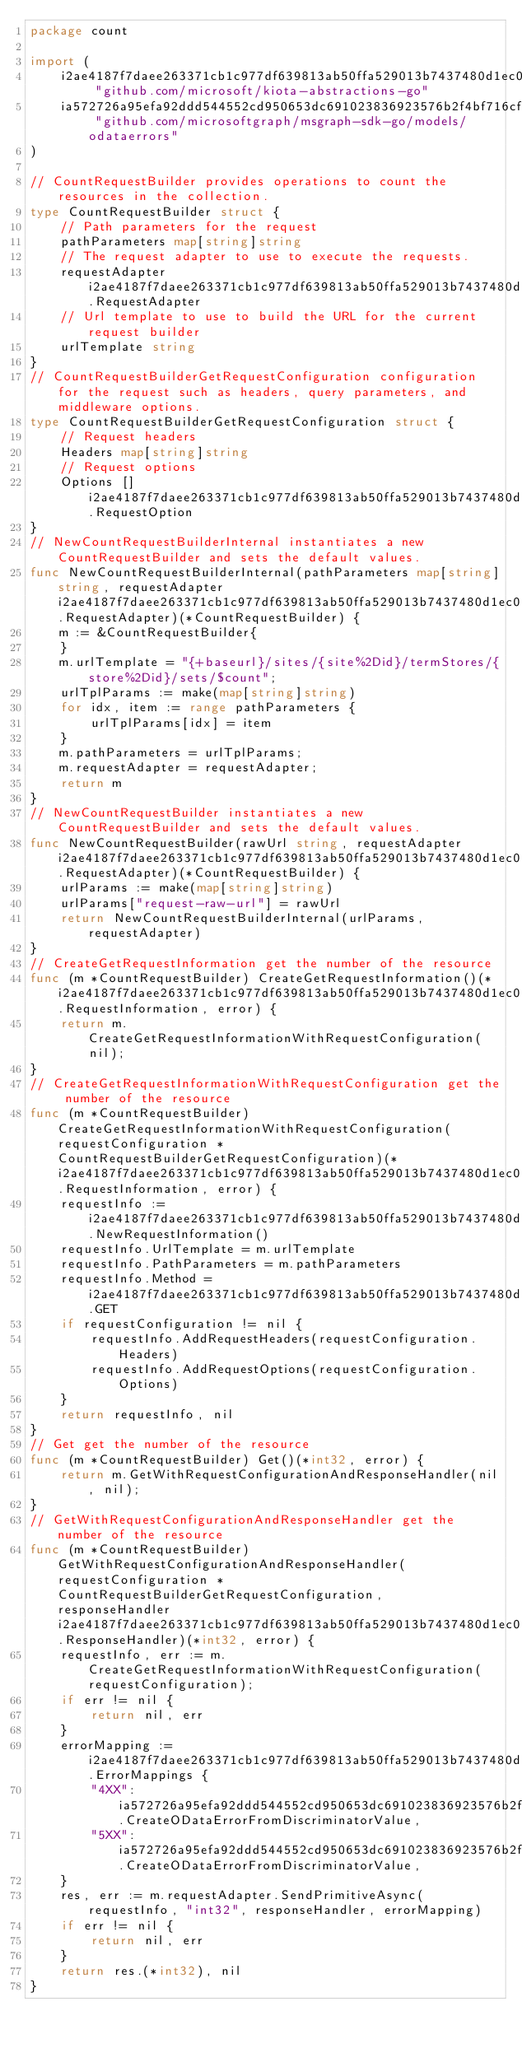Convert code to text. <code><loc_0><loc_0><loc_500><loc_500><_Go_>package count

import (
    i2ae4187f7daee263371cb1c977df639813ab50ffa529013b7437480d1ec0158f "github.com/microsoft/kiota-abstractions-go"
    ia572726a95efa92ddd544552cd950653dc691023836923576b2f4bf716cf204a "github.com/microsoftgraph/msgraph-sdk-go/models/odataerrors"
)

// CountRequestBuilder provides operations to count the resources in the collection.
type CountRequestBuilder struct {
    // Path parameters for the request
    pathParameters map[string]string
    // The request adapter to use to execute the requests.
    requestAdapter i2ae4187f7daee263371cb1c977df639813ab50ffa529013b7437480d1ec0158f.RequestAdapter
    // Url template to use to build the URL for the current request builder
    urlTemplate string
}
// CountRequestBuilderGetRequestConfiguration configuration for the request such as headers, query parameters, and middleware options.
type CountRequestBuilderGetRequestConfiguration struct {
    // Request headers
    Headers map[string]string
    // Request options
    Options []i2ae4187f7daee263371cb1c977df639813ab50ffa529013b7437480d1ec0158f.RequestOption
}
// NewCountRequestBuilderInternal instantiates a new CountRequestBuilder and sets the default values.
func NewCountRequestBuilderInternal(pathParameters map[string]string, requestAdapter i2ae4187f7daee263371cb1c977df639813ab50ffa529013b7437480d1ec0158f.RequestAdapter)(*CountRequestBuilder) {
    m := &CountRequestBuilder{
    }
    m.urlTemplate = "{+baseurl}/sites/{site%2Did}/termStores/{store%2Did}/sets/$count";
    urlTplParams := make(map[string]string)
    for idx, item := range pathParameters {
        urlTplParams[idx] = item
    }
    m.pathParameters = urlTplParams;
    m.requestAdapter = requestAdapter;
    return m
}
// NewCountRequestBuilder instantiates a new CountRequestBuilder and sets the default values.
func NewCountRequestBuilder(rawUrl string, requestAdapter i2ae4187f7daee263371cb1c977df639813ab50ffa529013b7437480d1ec0158f.RequestAdapter)(*CountRequestBuilder) {
    urlParams := make(map[string]string)
    urlParams["request-raw-url"] = rawUrl
    return NewCountRequestBuilderInternal(urlParams, requestAdapter)
}
// CreateGetRequestInformation get the number of the resource
func (m *CountRequestBuilder) CreateGetRequestInformation()(*i2ae4187f7daee263371cb1c977df639813ab50ffa529013b7437480d1ec0158f.RequestInformation, error) {
    return m.CreateGetRequestInformationWithRequestConfiguration(nil);
}
// CreateGetRequestInformationWithRequestConfiguration get the number of the resource
func (m *CountRequestBuilder) CreateGetRequestInformationWithRequestConfiguration(requestConfiguration *CountRequestBuilderGetRequestConfiguration)(*i2ae4187f7daee263371cb1c977df639813ab50ffa529013b7437480d1ec0158f.RequestInformation, error) {
    requestInfo := i2ae4187f7daee263371cb1c977df639813ab50ffa529013b7437480d1ec0158f.NewRequestInformation()
    requestInfo.UrlTemplate = m.urlTemplate
    requestInfo.PathParameters = m.pathParameters
    requestInfo.Method = i2ae4187f7daee263371cb1c977df639813ab50ffa529013b7437480d1ec0158f.GET
    if requestConfiguration != nil {
        requestInfo.AddRequestHeaders(requestConfiguration.Headers)
        requestInfo.AddRequestOptions(requestConfiguration.Options)
    }
    return requestInfo, nil
}
// Get get the number of the resource
func (m *CountRequestBuilder) Get()(*int32, error) {
    return m.GetWithRequestConfigurationAndResponseHandler(nil, nil);
}
// GetWithRequestConfigurationAndResponseHandler get the number of the resource
func (m *CountRequestBuilder) GetWithRequestConfigurationAndResponseHandler(requestConfiguration *CountRequestBuilderGetRequestConfiguration, responseHandler i2ae4187f7daee263371cb1c977df639813ab50ffa529013b7437480d1ec0158f.ResponseHandler)(*int32, error) {
    requestInfo, err := m.CreateGetRequestInformationWithRequestConfiguration(requestConfiguration);
    if err != nil {
        return nil, err
    }
    errorMapping := i2ae4187f7daee263371cb1c977df639813ab50ffa529013b7437480d1ec0158f.ErrorMappings {
        "4XX": ia572726a95efa92ddd544552cd950653dc691023836923576b2f4bf716cf204a.CreateODataErrorFromDiscriminatorValue,
        "5XX": ia572726a95efa92ddd544552cd950653dc691023836923576b2f4bf716cf204a.CreateODataErrorFromDiscriminatorValue,
    }
    res, err := m.requestAdapter.SendPrimitiveAsync(requestInfo, "int32", responseHandler, errorMapping)
    if err != nil {
        return nil, err
    }
    return res.(*int32), nil
}
</code> 